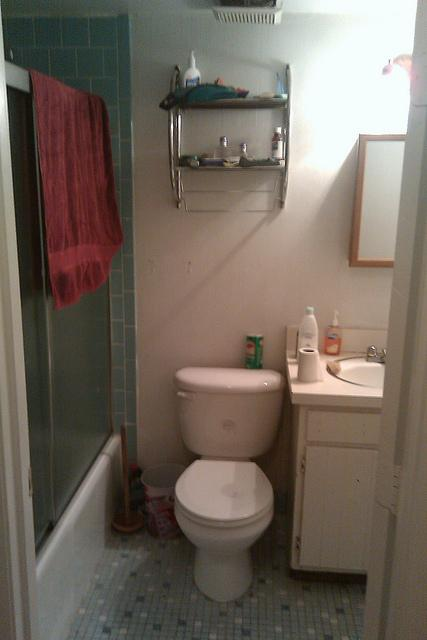What is in the container on the toilet tank? Please explain your reasoning. cleanser. This is a cleaning product you can use to clean the tub or sink with. 